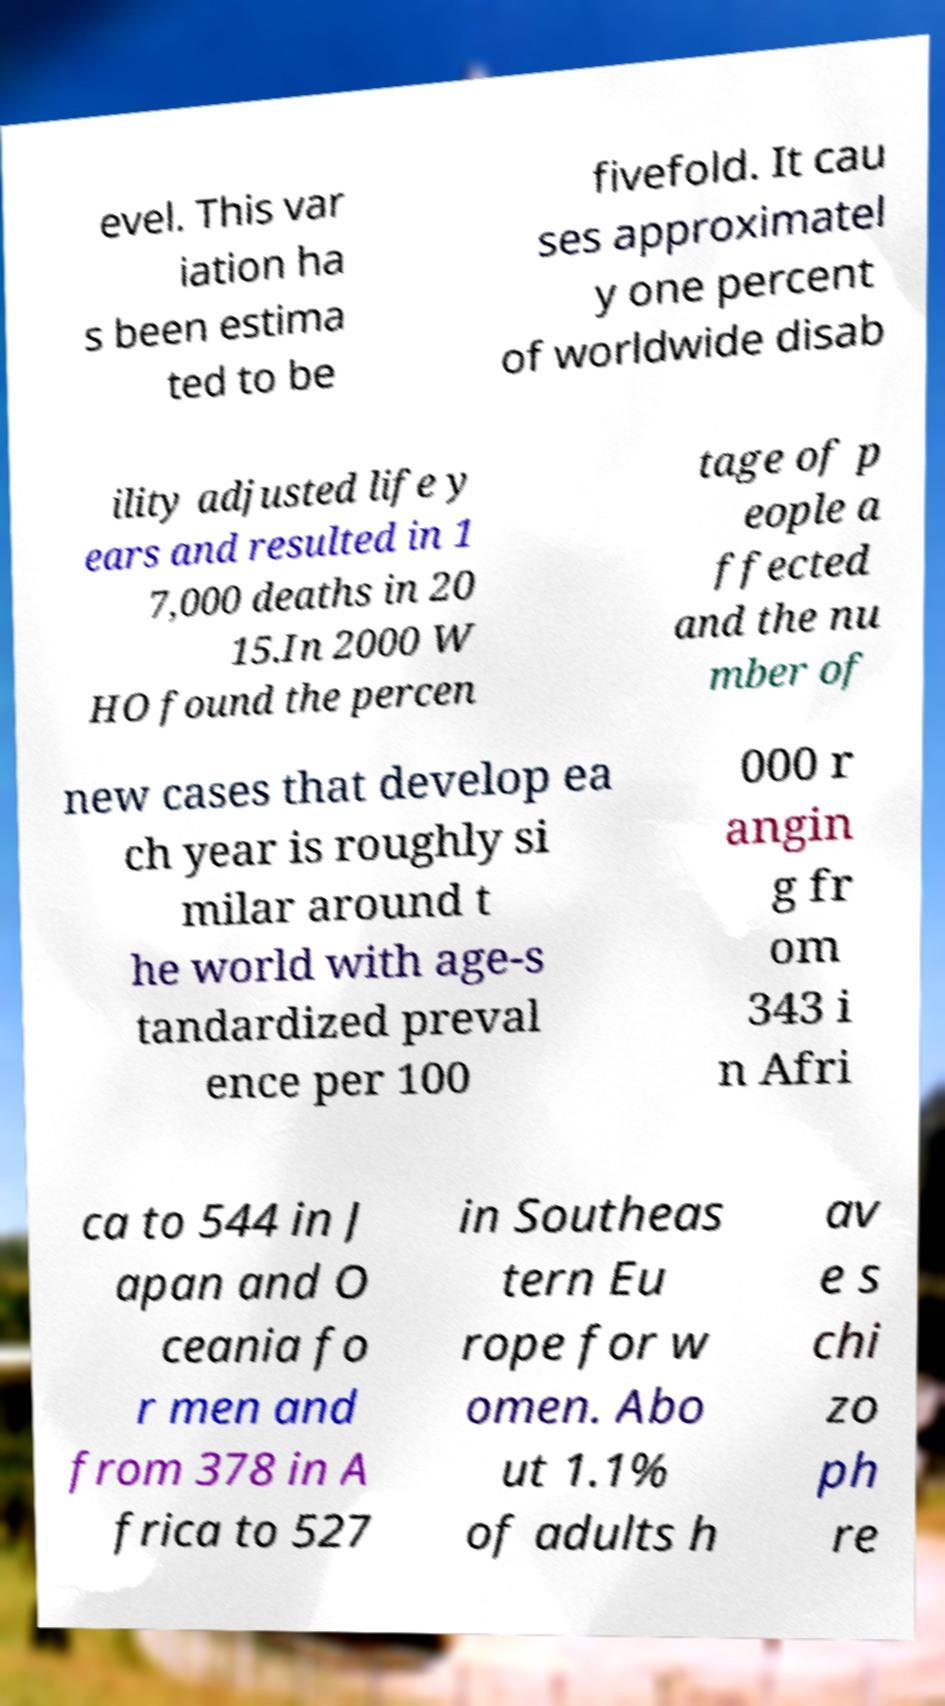There's text embedded in this image that I need extracted. Can you transcribe it verbatim? evel. This var iation ha s been estima ted to be fivefold. It cau ses approximatel y one percent of worldwide disab ility adjusted life y ears and resulted in 1 7,000 deaths in 20 15.In 2000 W HO found the percen tage of p eople a ffected and the nu mber of new cases that develop ea ch year is roughly si milar around t he world with age-s tandardized preval ence per 100 000 r angin g fr om 343 i n Afri ca to 544 in J apan and O ceania fo r men and from 378 in A frica to 527 in Southeas tern Eu rope for w omen. Abo ut 1.1% of adults h av e s chi zo ph re 